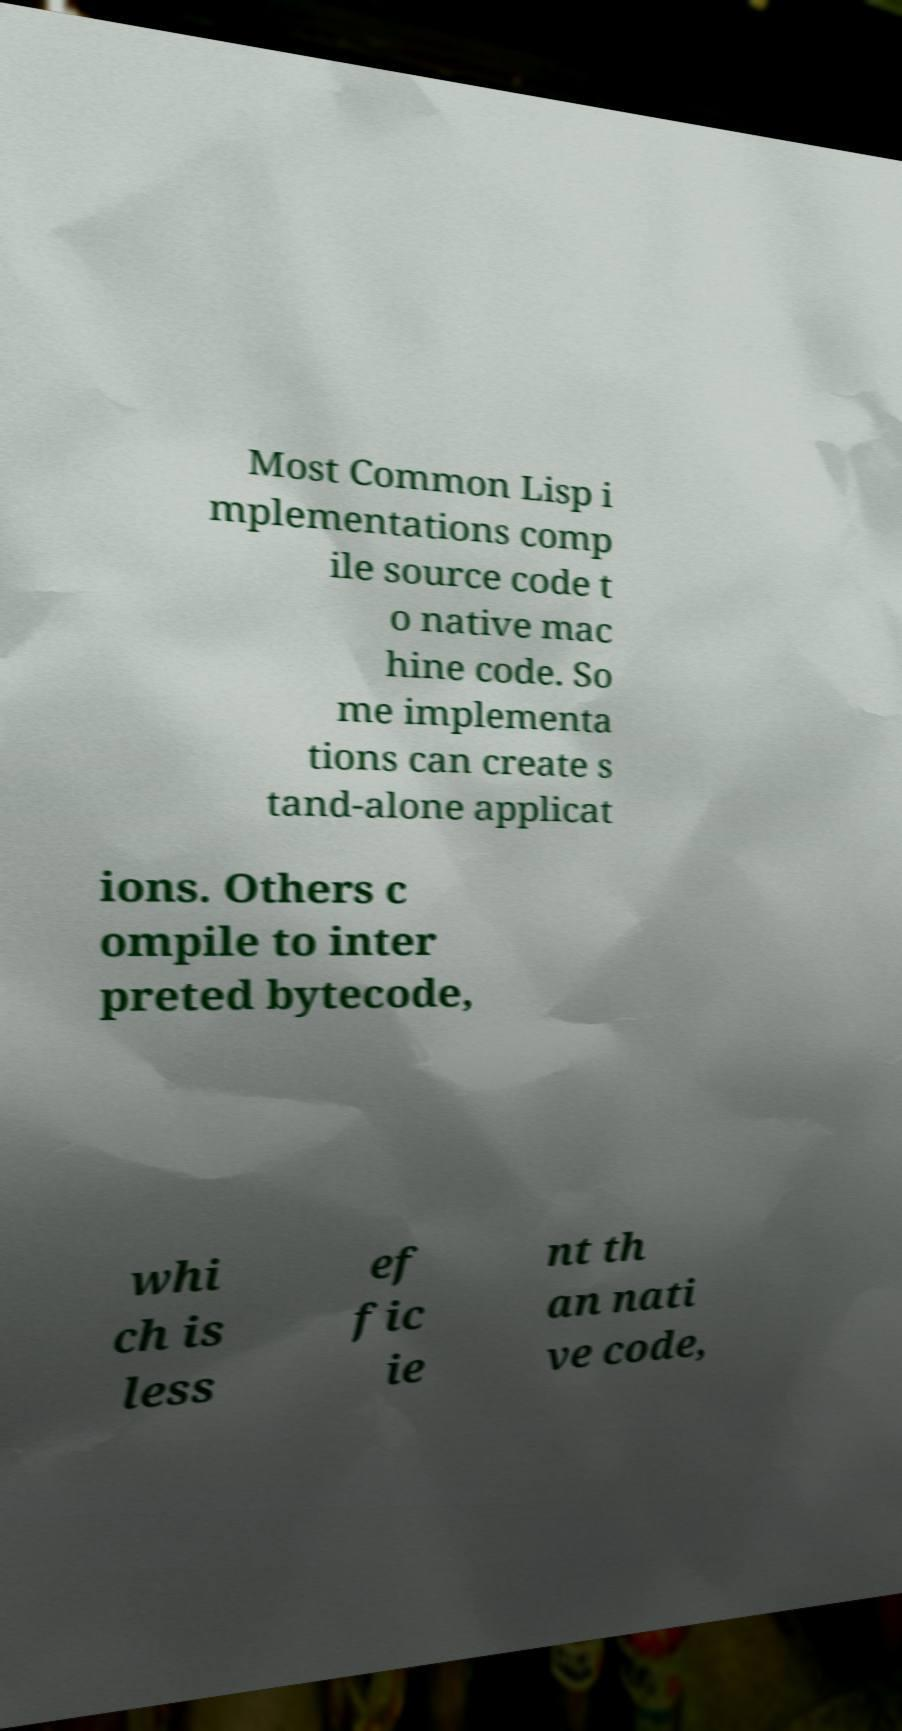Can you accurately transcribe the text from the provided image for me? Most Common Lisp i mplementations comp ile source code t o native mac hine code. So me implementa tions can create s tand-alone applicat ions. Others c ompile to inter preted bytecode, whi ch is less ef fic ie nt th an nati ve code, 